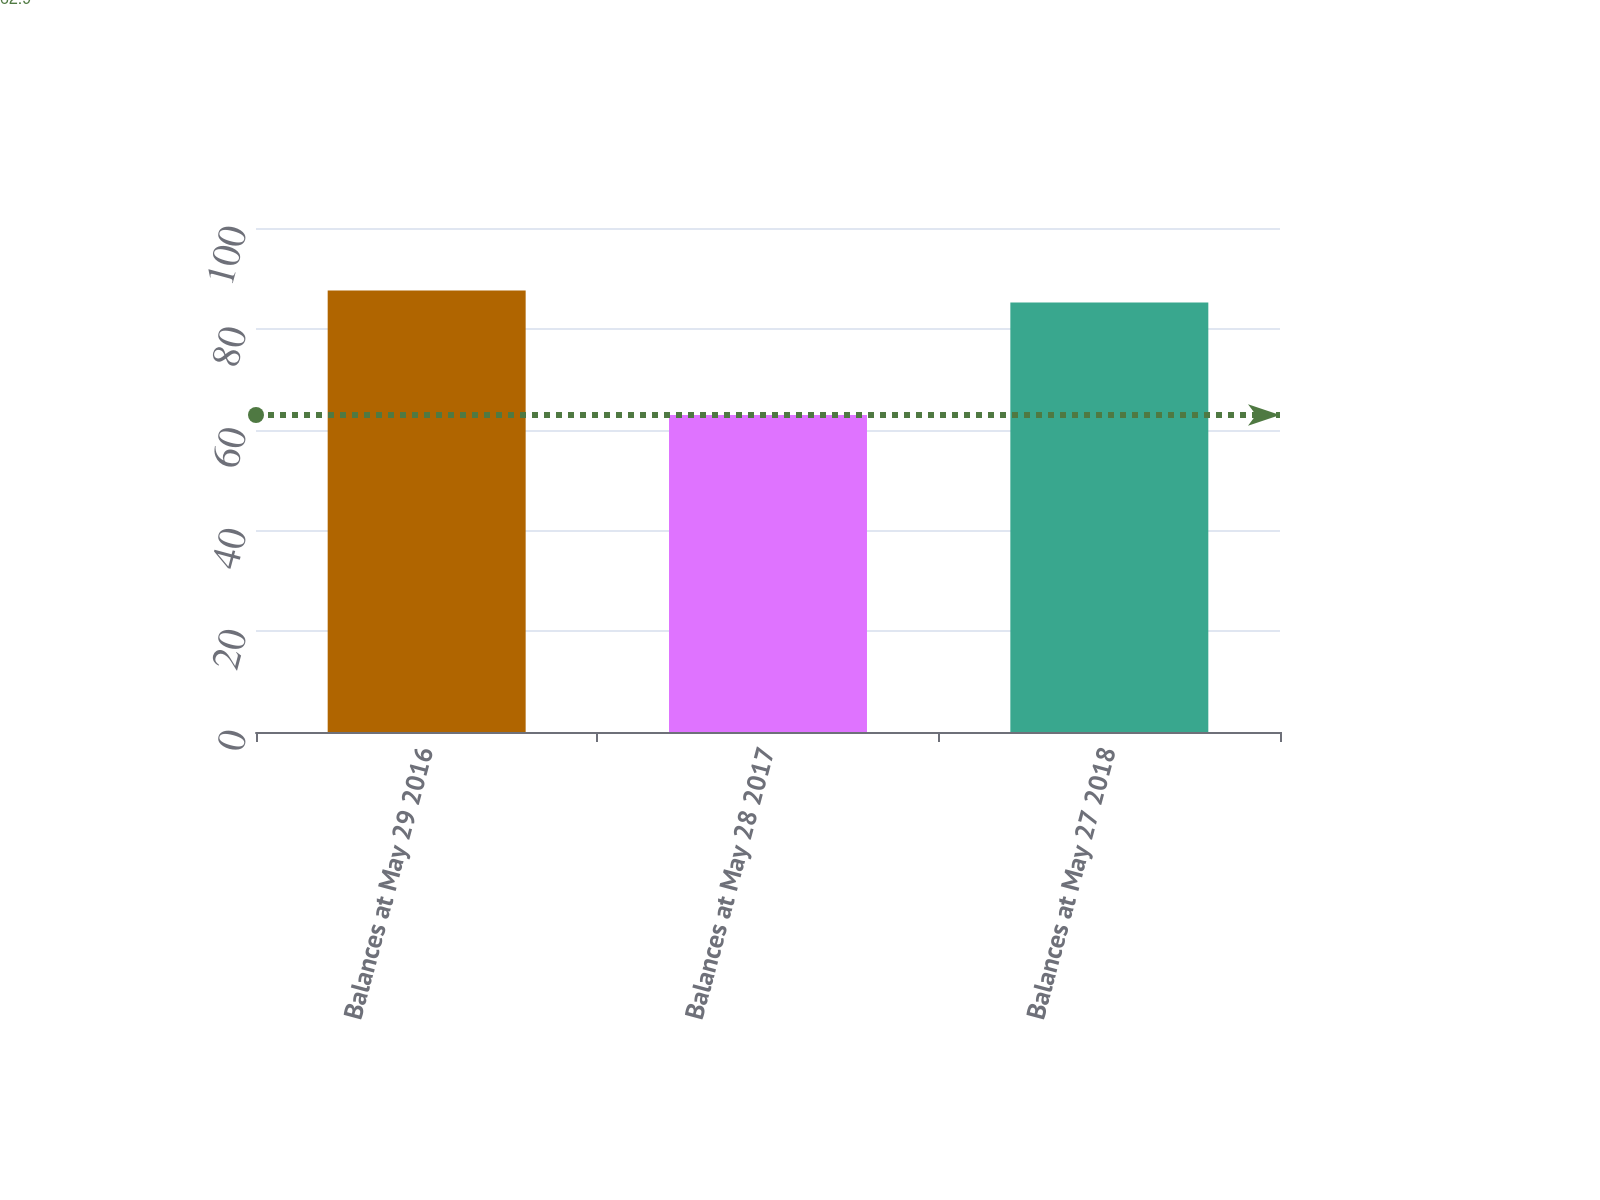Convert chart to OTSL. <chart><loc_0><loc_0><loc_500><loc_500><bar_chart><fcel>Balances at May 29 2016<fcel>Balances at May 28 2017<fcel>Balances at May 27 2018<nl><fcel>87.61<fcel>62.9<fcel>85.2<nl></chart> 